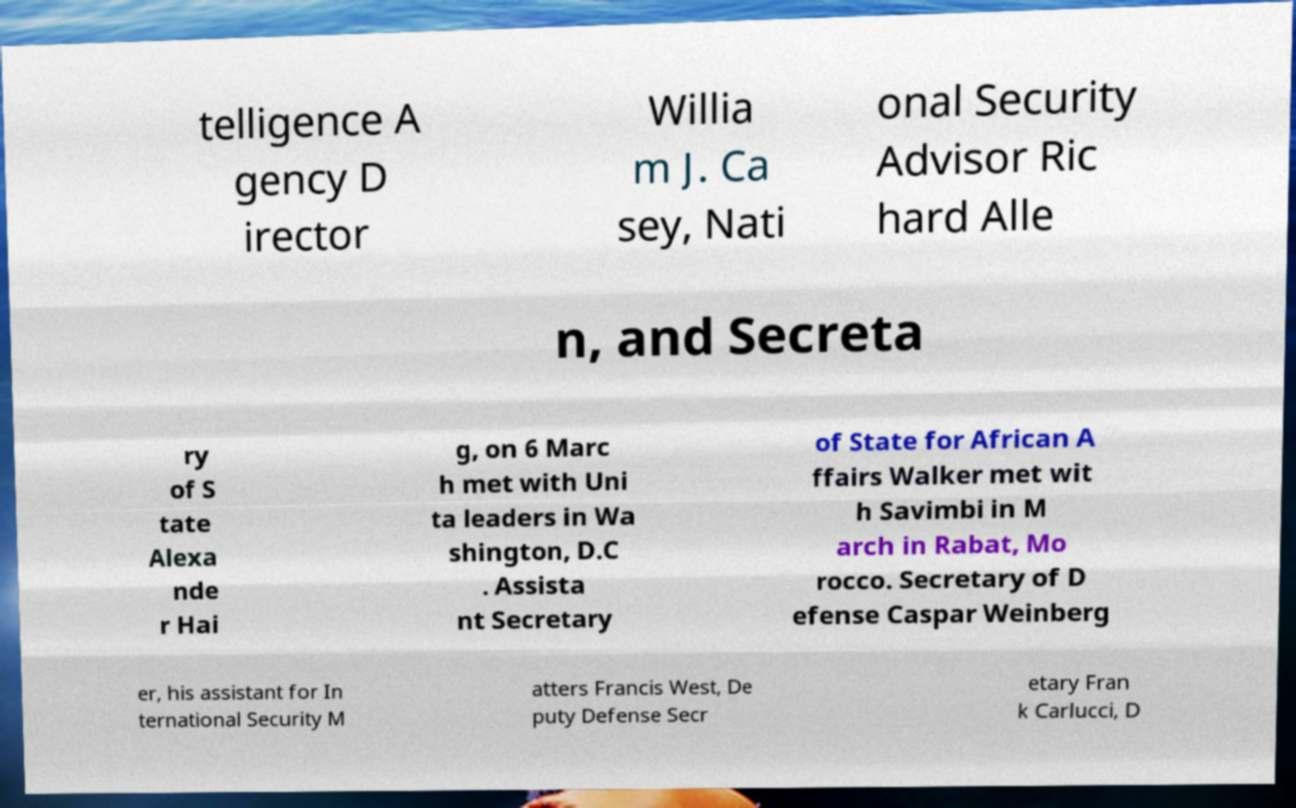Please identify and transcribe the text found in this image. telligence A gency D irector Willia m J. Ca sey, Nati onal Security Advisor Ric hard Alle n, and Secreta ry of S tate Alexa nde r Hai g, on 6 Marc h met with Uni ta leaders in Wa shington, D.C . Assista nt Secretary of State for African A ffairs Walker met wit h Savimbi in M arch in Rabat, Mo rocco. Secretary of D efense Caspar Weinberg er, his assistant for In ternational Security M atters Francis West, De puty Defense Secr etary Fran k Carlucci, D 